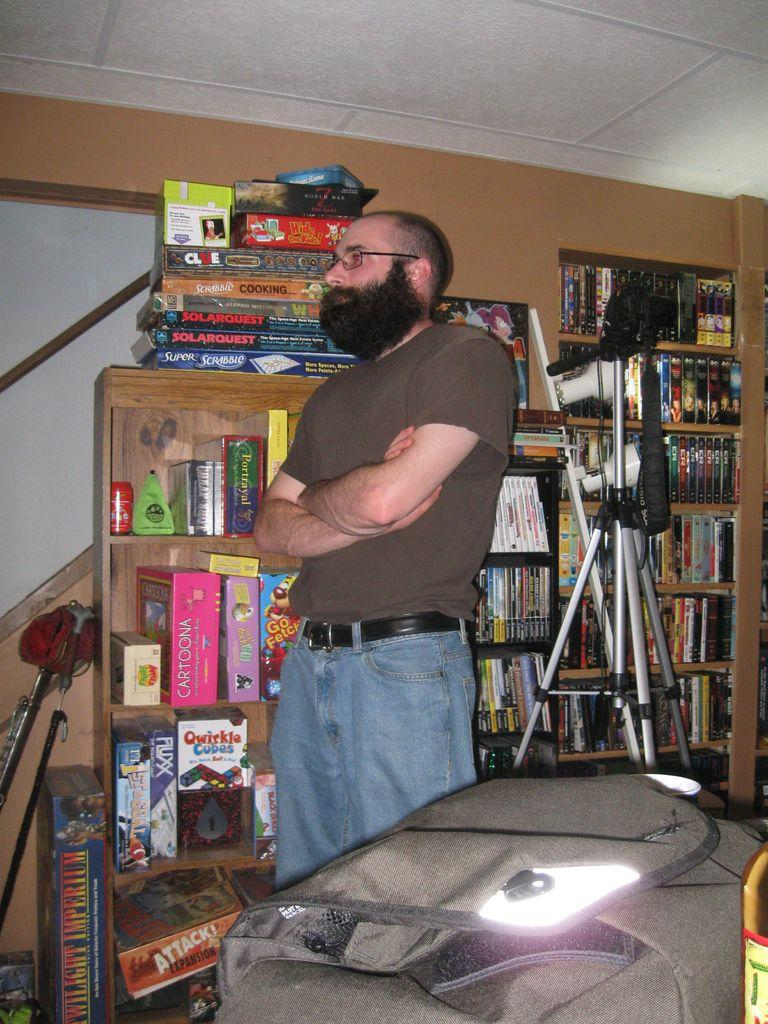<image>
Summarize the visual content of the image. A man stands in front of a shelf with lots of games on it including Cartoona and Go Fetch. 